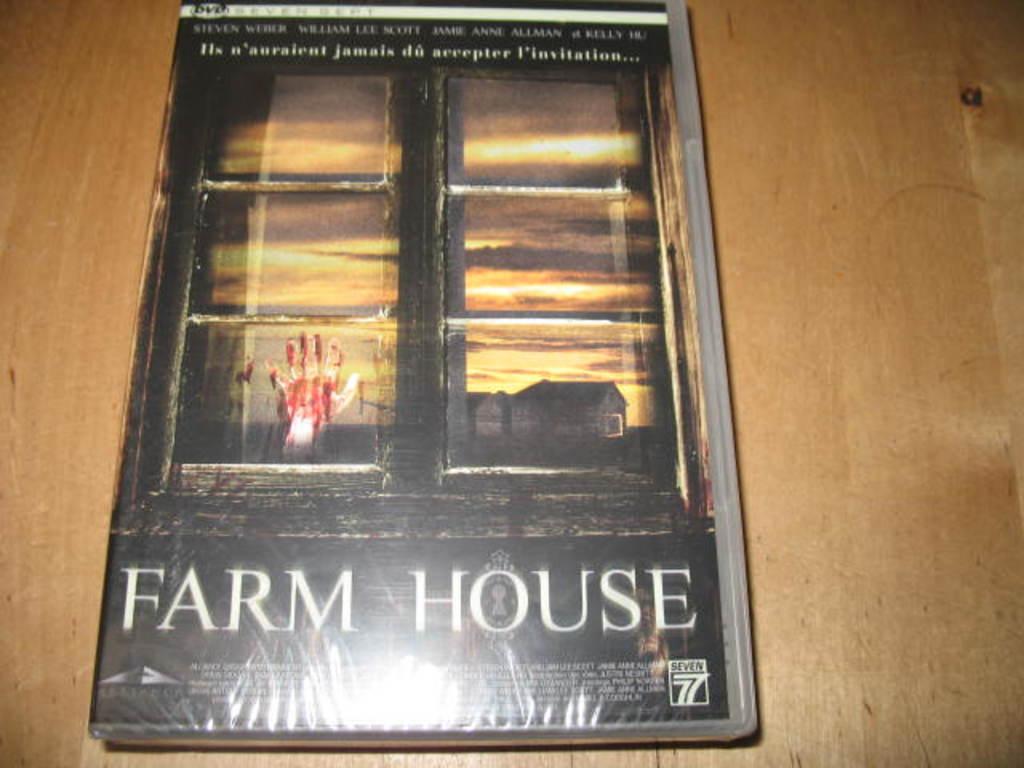What type of house?
Offer a terse response. Farm. 